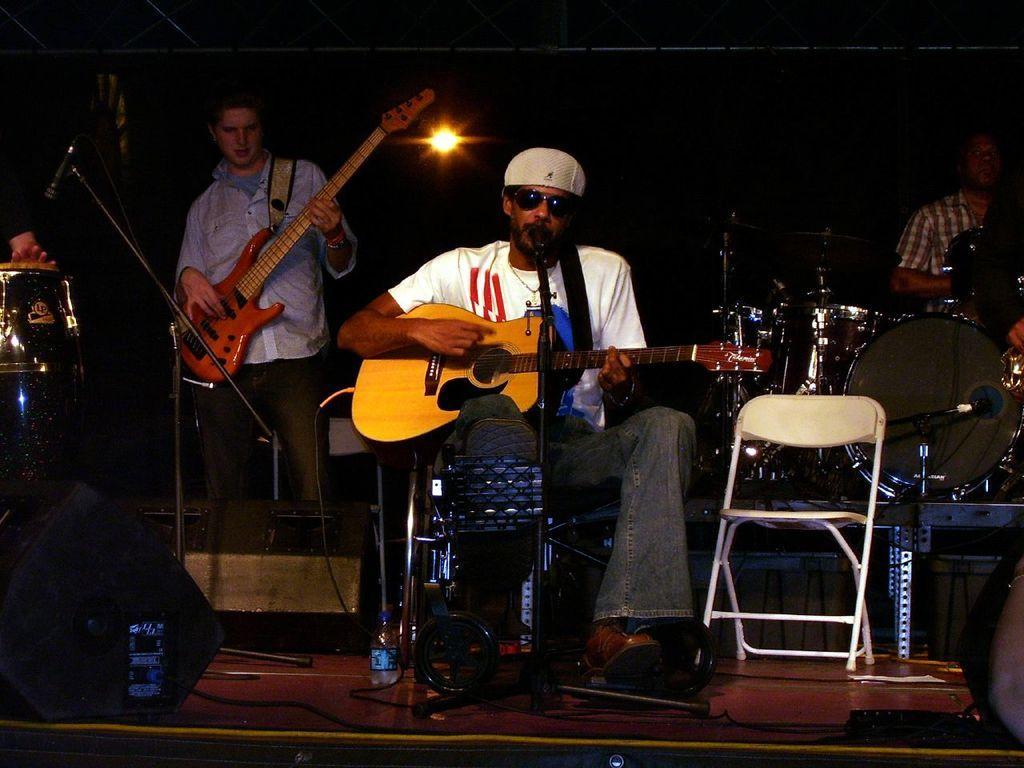Could you give a brief overview of what you see in this image? Here we can see a band who is performing on the stage, the guy in the center is sitting on a chair and he is playing guitar and there is a microphone in front of him and the guy in the right side is playing drums and same at the left side is also playing drums, and the guy beside him is playing a guitar 